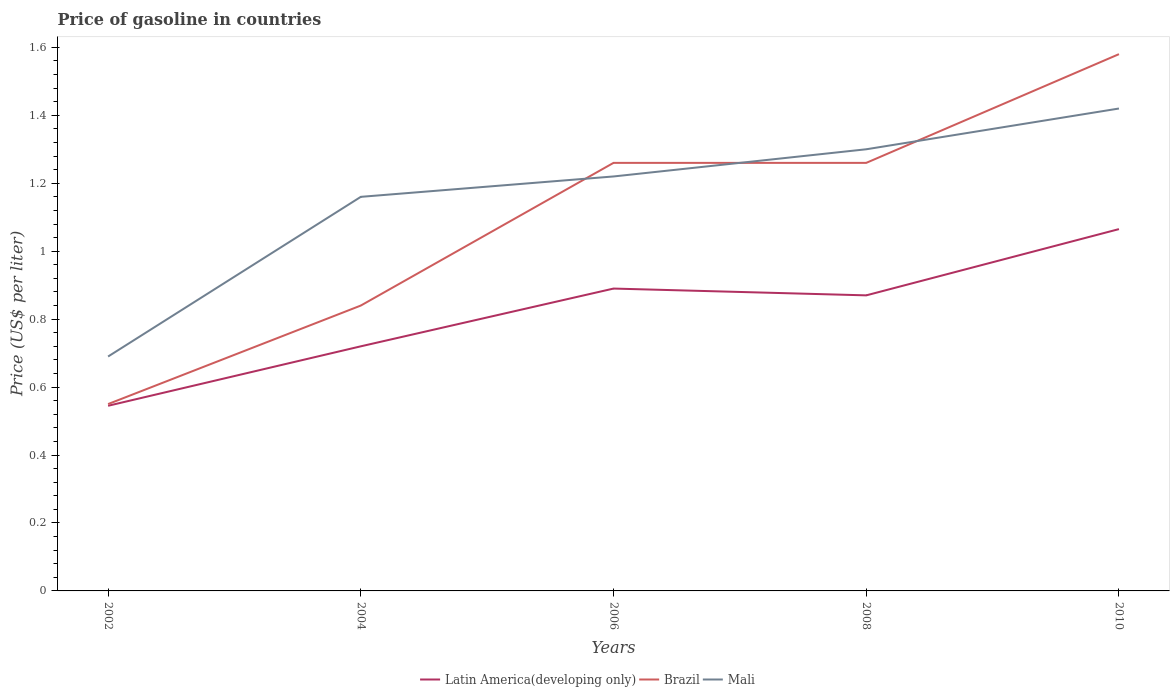Is the number of lines equal to the number of legend labels?
Your response must be concise. Yes. Across all years, what is the maximum price of gasoline in Mali?
Your answer should be very brief. 0.69. What is the total price of gasoline in Brazil in the graph?
Provide a short and direct response. -0.74. What is the difference between the highest and the second highest price of gasoline in Mali?
Your answer should be very brief. 0.73. What is the difference between the highest and the lowest price of gasoline in Brazil?
Your response must be concise. 3. How many years are there in the graph?
Your response must be concise. 5. What is the difference between two consecutive major ticks on the Y-axis?
Keep it short and to the point. 0.2. Are the values on the major ticks of Y-axis written in scientific E-notation?
Offer a very short reply. No. Does the graph contain grids?
Give a very brief answer. No. How are the legend labels stacked?
Provide a succinct answer. Horizontal. What is the title of the graph?
Your response must be concise. Price of gasoline in countries. Does "South Asia" appear as one of the legend labels in the graph?
Offer a terse response. No. What is the label or title of the Y-axis?
Ensure brevity in your answer.  Price (US$ per liter). What is the Price (US$ per liter) of Latin America(developing only) in 2002?
Your response must be concise. 0.55. What is the Price (US$ per liter) in Brazil in 2002?
Make the answer very short. 0.55. What is the Price (US$ per liter) in Mali in 2002?
Your response must be concise. 0.69. What is the Price (US$ per liter) of Latin America(developing only) in 2004?
Your answer should be very brief. 0.72. What is the Price (US$ per liter) of Brazil in 2004?
Your answer should be very brief. 0.84. What is the Price (US$ per liter) of Mali in 2004?
Your answer should be compact. 1.16. What is the Price (US$ per liter) of Latin America(developing only) in 2006?
Your answer should be very brief. 0.89. What is the Price (US$ per liter) of Brazil in 2006?
Ensure brevity in your answer.  1.26. What is the Price (US$ per liter) in Mali in 2006?
Offer a terse response. 1.22. What is the Price (US$ per liter) in Latin America(developing only) in 2008?
Provide a succinct answer. 0.87. What is the Price (US$ per liter) of Brazil in 2008?
Your answer should be compact. 1.26. What is the Price (US$ per liter) of Mali in 2008?
Offer a terse response. 1.3. What is the Price (US$ per liter) of Latin America(developing only) in 2010?
Give a very brief answer. 1.06. What is the Price (US$ per liter) in Brazil in 2010?
Provide a succinct answer. 1.58. What is the Price (US$ per liter) in Mali in 2010?
Offer a very short reply. 1.42. Across all years, what is the maximum Price (US$ per liter) of Latin America(developing only)?
Keep it short and to the point. 1.06. Across all years, what is the maximum Price (US$ per liter) of Brazil?
Ensure brevity in your answer.  1.58. Across all years, what is the maximum Price (US$ per liter) in Mali?
Your response must be concise. 1.42. Across all years, what is the minimum Price (US$ per liter) of Latin America(developing only)?
Give a very brief answer. 0.55. Across all years, what is the minimum Price (US$ per liter) in Brazil?
Give a very brief answer. 0.55. Across all years, what is the minimum Price (US$ per liter) in Mali?
Ensure brevity in your answer.  0.69. What is the total Price (US$ per liter) in Latin America(developing only) in the graph?
Ensure brevity in your answer.  4.09. What is the total Price (US$ per liter) in Brazil in the graph?
Offer a terse response. 5.49. What is the total Price (US$ per liter) in Mali in the graph?
Your response must be concise. 5.79. What is the difference between the Price (US$ per liter) in Latin America(developing only) in 2002 and that in 2004?
Keep it short and to the point. -0.17. What is the difference between the Price (US$ per liter) of Brazil in 2002 and that in 2004?
Provide a short and direct response. -0.29. What is the difference between the Price (US$ per liter) in Mali in 2002 and that in 2004?
Offer a very short reply. -0.47. What is the difference between the Price (US$ per liter) in Latin America(developing only) in 2002 and that in 2006?
Your answer should be compact. -0.34. What is the difference between the Price (US$ per liter) of Brazil in 2002 and that in 2006?
Your answer should be very brief. -0.71. What is the difference between the Price (US$ per liter) in Mali in 2002 and that in 2006?
Make the answer very short. -0.53. What is the difference between the Price (US$ per liter) in Latin America(developing only) in 2002 and that in 2008?
Your response must be concise. -0.33. What is the difference between the Price (US$ per liter) of Brazil in 2002 and that in 2008?
Your response must be concise. -0.71. What is the difference between the Price (US$ per liter) in Mali in 2002 and that in 2008?
Your response must be concise. -0.61. What is the difference between the Price (US$ per liter) in Latin America(developing only) in 2002 and that in 2010?
Offer a very short reply. -0.52. What is the difference between the Price (US$ per liter) of Brazil in 2002 and that in 2010?
Offer a very short reply. -1.03. What is the difference between the Price (US$ per liter) in Mali in 2002 and that in 2010?
Make the answer very short. -0.73. What is the difference between the Price (US$ per liter) in Latin America(developing only) in 2004 and that in 2006?
Your response must be concise. -0.17. What is the difference between the Price (US$ per liter) in Brazil in 2004 and that in 2006?
Keep it short and to the point. -0.42. What is the difference between the Price (US$ per liter) of Mali in 2004 and that in 2006?
Keep it short and to the point. -0.06. What is the difference between the Price (US$ per liter) in Latin America(developing only) in 2004 and that in 2008?
Offer a very short reply. -0.15. What is the difference between the Price (US$ per liter) in Brazil in 2004 and that in 2008?
Your answer should be very brief. -0.42. What is the difference between the Price (US$ per liter) of Mali in 2004 and that in 2008?
Provide a succinct answer. -0.14. What is the difference between the Price (US$ per liter) in Latin America(developing only) in 2004 and that in 2010?
Provide a succinct answer. -0.34. What is the difference between the Price (US$ per liter) in Brazil in 2004 and that in 2010?
Your answer should be very brief. -0.74. What is the difference between the Price (US$ per liter) of Mali in 2004 and that in 2010?
Provide a succinct answer. -0.26. What is the difference between the Price (US$ per liter) of Mali in 2006 and that in 2008?
Provide a short and direct response. -0.08. What is the difference between the Price (US$ per liter) of Latin America(developing only) in 2006 and that in 2010?
Offer a terse response. -0.17. What is the difference between the Price (US$ per liter) of Brazil in 2006 and that in 2010?
Your response must be concise. -0.32. What is the difference between the Price (US$ per liter) in Latin America(developing only) in 2008 and that in 2010?
Provide a short and direct response. -0.2. What is the difference between the Price (US$ per liter) in Brazil in 2008 and that in 2010?
Your response must be concise. -0.32. What is the difference between the Price (US$ per liter) in Mali in 2008 and that in 2010?
Give a very brief answer. -0.12. What is the difference between the Price (US$ per liter) of Latin America(developing only) in 2002 and the Price (US$ per liter) of Brazil in 2004?
Keep it short and to the point. -0.29. What is the difference between the Price (US$ per liter) of Latin America(developing only) in 2002 and the Price (US$ per liter) of Mali in 2004?
Offer a terse response. -0.61. What is the difference between the Price (US$ per liter) in Brazil in 2002 and the Price (US$ per liter) in Mali in 2004?
Offer a very short reply. -0.61. What is the difference between the Price (US$ per liter) in Latin America(developing only) in 2002 and the Price (US$ per liter) in Brazil in 2006?
Keep it short and to the point. -0.71. What is the difference between the Price (US$ per liter) of Latin America(developing only) in 2002 and the Price (US$ per liter) of Mali in 2006?
Provide a succinct answer. -0.68. What is the difference between the Price (US$ per liter) in Brazil in 2002 and the Price (US$ per liter) in Mali in 2006?
Offer a terse response. -0.67. What is the difference between the Price (US$ per liter) in Latin America(developing only) in 2002 and the Price (US$ per liter) in Brazil in 2008?
Ensure brevity in your answer.  -0.71. What is the difference between the Price (US$ per liter) of Latin America(developing only) in 2002 and the Price (US$ per liter) of Mali in 2008?
Ensure brevity in your answer.  -0.76. What is the difference between the Price (US$ per liter) in Brazil in 2002 and the Price (US$ per liter) in Mali in 2008?
Provide a short and direct response. -0.75. What is the difference between the Price (US$ per liter) of Latin America(developing only) in 2002 and the Price (US$ per liter) of Brazil in 2010?
Your answer should be compact. -1.03. What is the difference between the Price (US$ per liter) of Latin America(developing only) in 2002 and the Price (US$ per liter) of Mali in 2010?
Offer a very short reply. -0.88. What is the difference between the Price (US$ per liter) in Brazil in 2002 and the Price (US$ per liter) in Mali in 2010?
Your response must be concise. -0.87. What is the difference between the Price (US$ per liter) in Latin America(developing only) in 2004 and the Price (US$ per liter) in Brazil in 2006?
Give a very brief answer. -0.54. What is the difference between the Price (US$ per liter) in Brazil in 2004 and the Price (US$ per liter) in Mali in 2006?
Your answer should be very brief. -0.38. What is the difference between the Price (US$ per liter) of Latin America(developing only) in 2004 and the Price (US$ per liter) of Brazil in 2008?
Your answer should be very brief. -0.54. What is the difference between the Price (US$ per liter) in Latin America(developing only) in 2004 and the Price (US$ per liter) in Mali in 2008?
Give a very brief answer. -0.58. What is the difference between the Price (US$ per liter) of Brazil in 2004 and the Price (US$ per liter) of Mali in 2008?
Your answer should be very brief. -0.46. What is the difference between the Price (US$ per liter) in Latin America(developing only) in 2004 and the Price (US$ per liter) in Brazil in 2010?
Make the answer very short. -0.86. What is the difference between the Price (US$ per liter) in Latin America(developing only) in 2004 and the Price (US$ per liter) in Mali in 2010?
Keep it short and to the point. -0.7. What is the difference between the Price (US$ per liter) in Brazil in 2004 and the Price (US$ per liter) in Mali in 2010?
Keep it short and to the point. -0.58. What is the difference between the Price (US$ per liter) of Latin America(developing only) in 2006 and the Price (US$ per liter) of Brazil in 2008?
Make the answer very short. -0.37. What is the difference between the Price (US$ per liter) of Latin America(developing only) in 2006 and the Price (US$ per liter) of Mali in 2008?
Your response must be concise. -0.41. What is the difference between the Price (US$ per liter) of Brazil in 2006 and the Price (US$ per liter) of Mali in 2008?
Give a very brief answer. -0.04. What is the difference between the Price (US$ per liter) in Latin America(developing only) in 2006 and the Price (US$ per liter) in Brazil in 2010?
Provide a short and direct response. -0.69. What is the difference between the Price (US$ per liter) of Latin America(developing only) in 2006 and the Price (US$ per liter) of Mali in 2010?
Your answer should be very brief. -0.53. What is the difference between the Price (US$ per liter) of Brazil in 2006 and the Price (US$ per liter) of Mali in 2010?
Your response must be concise. -0.16. What is the difference between the Price (US$ per liter) in Latin America(developing only) in 2008 and the Price (US$ per liter) in Brazil in 2010?
Your response must be concise. -0.71. What is the difference between the Price (US$ per liter) in Latin America(developing only) in 2008 and the Price (US$ per liter) in Mali in 2010?
Keep it short and to the point. -0.55. What is the difference between the Price (US$ per liter) of Brazil in 2008 and the Price (US$ per liter) of Mali in 2010?
Your answer should be compact. -0.16. What is the average Price (US$ per liter) in Latin America(developing only) per year?
Offer a very short reply. 0.82. What is the average Price (US$ per liter) of Brazil per year?
Offer a terse response. 1.1. What is the average Price (US$ per liter) in Mali per year?
Provide a short and direct response. 1.16. In the year 2002, what is the difference between the Price (US$ per liter) in Latin America(developing only) and Price (US$ per liter) in Brazil?
Make the answer very short. -0.01. In the year 2002, what is the difference between the Price (US$ per liter) in Latin America(developing only) and Price (US$ per liter) in Mali?
Your answer should be compact. -0.14. In the year 2002, what is the difference between the Price (US$ per liter) of Brazil and Price (US$ per liter) of Mali?
Make the answer very short. -0.14. In the year 2004, what is the difference between the Price (US$ per liter) of Latin America(developing only) and Price (US$ per liter) of Brazil?
Give a very brief answer. -0.12. In the year 2004, what is the difference between the Price (US$ per liter) of Latin America(developing only) and Price (US$ per liter) of Mali?
Provide a short and direct response. -0.44. In the year 2004, what is the difference between the Price (US$ per liter) in Brazil and Price (US$ per liter) in Mali?
Provide a short and direct response. -0.32. In the year 2006, what is the difference between the Price (US$ per liter) in Latin America(developing only) and Price (US$ per liter) in Brazil?
Provide a short and direct response. -0.37. In the year 2006, what is the difference between the Price (US$ per liter) in Latin America(developing only) and Price (US$ per liter) in Mali?
Ensure brevity in your answer.  -0.33. In the year 2008, what is the difference between the Price (US$ per liter) in Latin America(developing only) and Price (US$ per liter) in Brazil?
Your answer should be very brief. -0.39. In the year 2008, what is the difference between the Price (US$ per liter) in Latin America(developing only) and Price (US$ per liter) in Mali?
Offer a terse response. -0.43. In the year 2008, what is the difference between the Price (US$ per liter) in Brazil and Price (US$ per liter) in Mali?
Make the answer very short. -0.04. In the year 2010, what is the difference between the Price (US$ per liter) in Latin America(developing only) and Price (US$ per liter) in Brazil?
Your answer should be very brief. -0.52. In the year 2010, what is the difference between the Price (US$ per liter) in Latin America(developing only) and Price (US$ per liter) in Mali?
Your response must be concise. -0.35. In the year 2010, what is the difference between the Price (US$ per liter) in Brazil and Price (US$ per liter) in Mali?
Provide a short and direct response. 0.16. What is the ratio of the Price (US$ per liter) in Latin America(developing only) in 2002 to that in 2004?
Make the answer very short. 0.76. What is the ratio of the Price (US$ per liter) of Brazil in 2002 to that in 2004?
Give a very brief answer. 0.65. What is the ratio of the Price (US$ per liter) of Mali in 2002 to that in 2004?
Your answer should be very brief. 0.59. What is the ratio of the Price (US$ per liter) of Latin America(developing only) in 2002 to that in 2006?
Ensure brevity in your answer.  0.61. What is the ratio of the Price (US$ per liter) in Brazil in 2002 to that in 2006?
Your answer should be compact. 0.44. What is the ratio of the Price (US$ per liter) of Mali in 2002 to that in 2006?
Give a very brief answer. 0.57. What is the ratio of the Price (US$ per liter) in Latin America(developing only) in 2002 to that in 2008?
Ensure brevity in your answer.  0.63. What is the ratio of the Price (US$ per liter) of Brazil in 2002 to that in 2008?
Your response must be concise. 0.44. What is the ratio of the Price (US$ per liter) in Mali in 2002 to that in 2008?
Offer a very short reply. 0.53. What is the ratio of the Price (US$ per liter) of Latin America(developing only) in 2002 to that in 2010?
Provide a short and direct response. 0.51. What is the ratio of the Price (US$ per liter) of Brazil in 2002 to that in 2010?
Ensure brevity in your answer.  0.35. What is the ratio of the Price (US$ per liter) of Mali in 2002 to that in 2010?
Make the answer very short. 0.49. What is the ratio of the Price (US$ per liter) of Latin America(developing only) in 2004 to that in 2006?
Make the answer very short. 0.81. What is the ratio of the Price (US$ per liter) of Brazil in 2004 to that in 2006?
Provide a short and direct response. 0.67. What is the ratio of the Price (US$ per liter) in Mali in 2004 to that in 2006?
Offer a terse response. 0.95. What is the ratio of the Price (US$ per liter) of Latin America(developing only) in 2004 to that in 2008?
Your answer should be very brief. 0.83. What is the ratio of the Price (US$ per liter) in Mali in 2004 to that in 2008?
Keep it short and to the point. 0.89. What is the ratio of the Price (US$ per liter) in Latin America(developing only) in 2004 to that in 2010?
Keep it short and to the point. 0.68. What is the ratio of the Price (US$ per liter) of Brazil in 2004 to that in 2010?
Offer a terse response. 0.53. What is the ratio of the Price (US$ per liter) in Mali in 2004 to that in 2010?
Offer a very short reply. 0.82. What is the ratio of the Price (US$ per liter) of Latin America(developing only) in 2006 to that in 2008?
Provide a short and direct response. 1.02. What is the ratio of the Price (US$ per liter) in Mali in 2006 to that in 2008?
Your response must be concise. 0.94. What is the ratio of the Price (US$ per liter) of Latin America(developing only) in 2006 to that in 2010?
Provide a succinct answer. 0.84. What is the ratio of the Price (US$ per liter) of Brazil in 2006 to that in 2010?
Make the answer very short. 0.8. What is the ratio of the Price (US$ per liter) of Mali in 2006 to that in 2010?
Offer a very short reply. 0.86. What is the ratio of the Price (US$ per liter) of Latin America(developing only) in 2008 to that in 2010?
Keep it short and to the point. 0.82. What is the ratio of the Price (US$ per liter) of Brazil in 2008 to that in 2010?
Your response must be concise. 0.8. What is the ratio of the Price (US$ per liter) in Mali in 2008 to that in 2010?
Offer a very short reply. 0.92. What is the difference between the highest and the second highest Price (US$ per liter) in Latin America(developing only)?
Give a very brief answer. 0.17. What is the difference between the highest and the second highest Price (US$ per liter) of Brazil?
Your answer should be very brief. 0.32. What is the difference between the highest and the second highest Price (US$ per liter) in Mali?
Offer a terse response. 0.12. What is the difference between the highest and the lowest Price (US$ per liter) of Latin America(developing only)?
Your response must be concise. 0.52. What is the difference between the highest and the lowest Price (US$ per liter) in Brazil?
Provide a short and direct response. 1.03. What is the difference between the highest and the lowest Price (US$ per liter) in Mali?
Make the answer very short. 0.73. 